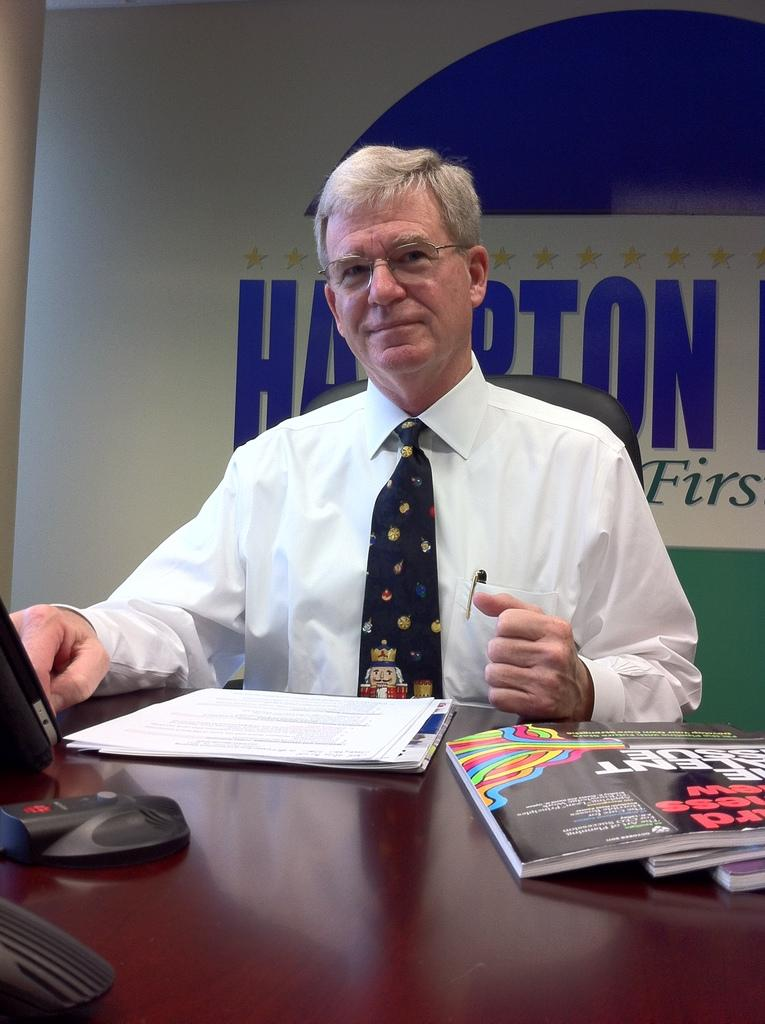Who is present in the image? There is a person in the image. What is the person doing in the image? The person is sitting. Where is the person located in relation to the table? The person is in front of a table. What items can be seen on the table? There are books and papers on the table. What type of tent can be seen in the background of the image? There is no tent present in the image; it features a person sitting in front of a table with books and papers. How many feet are visible in the image? The image does not show any feet; it only shows a person sitting in front of a table. 